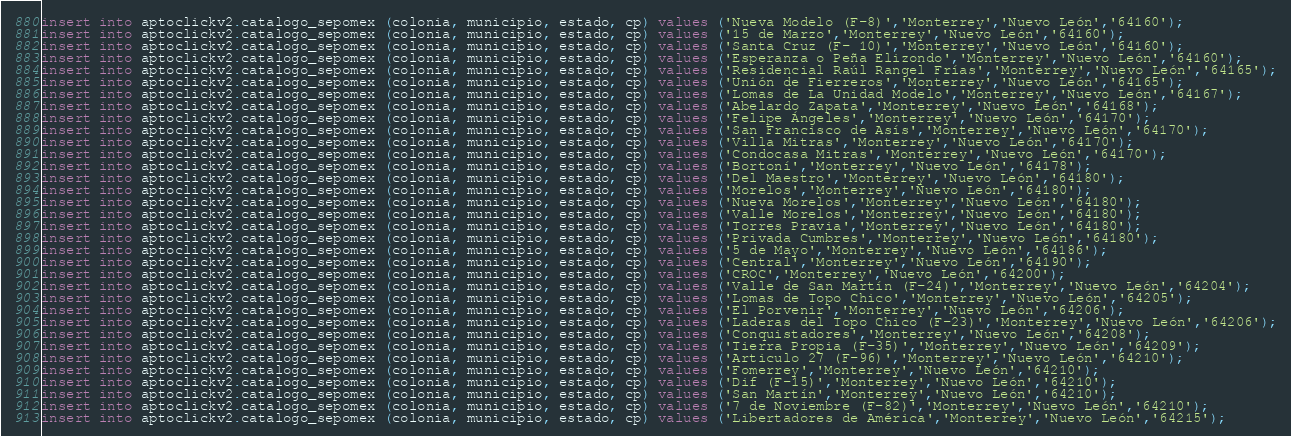Convert code to text. <code><loc_0><loc_0><loc_500><loc_500><_SQL_>insert into aptoclickv2.catalogo_sepomex (colonia, municipio, estado, cp) values ('Nueva Modelo (F-8)','Monterrey','Nuevo León','64160');
insert into aptoclickv2.catalogo_sepomex (colonia, municipio, estado, cp) values ('15 de Marzo','Monterrey','Nuevo León','64160');
insert into aptoclickv2.catalogo_sepomex (colonia, municipio, estado, cp) values ('Santa Cruz (F- 10)','Monterrey','Nuevo León','64160');
insert into aptoclickv2.catalogo_sepomex (colonia, municipio, estado, cp) values ('Esperanza o Peña Elizondo','Monterrey','Nuevo León','64160');
insert into aptoclickv2.catalogo_sepomex (colonia, municipio, estado, cp) values ('Residencial Raúl Rangel Frías','Monterrey','Nuevo León','64165');
insert into aptoclickv2.catalogo_sepomex (colonia, municipio, estado, cp) values ('Unión de Fierreros','Monterrey','Nuevo León','64165');
insert into aptoclickv2.catalogo_sepomex (colonia, municipio, estado, cp) values ('Lomas de La Unidad Modelo','Monterrey','Nuevo León','64167');
insert into aptoclickv2.catalogo_sepomex (colonia, municipio, estado, cp) values ('Abelardo Zapata','Monterrey','Nuevo León','64168');
insert into aptoclickv2.catalogo_sepomex (colonia, municipio, estado, cp) values ('Felipe Ángeles','Monterrey','Nuevo León','64170');
insert into aptoclickv2.catalogo_sepomex (colonia, municipio, estado, cp) values ('San Francisco de Asís','Monterrey','Nuevo León','64170');
insert into aptoclickv2.catalogo_sepomex (colonia, municipio, estado, cp) values ('Villa Mitras','Monterrey','Nuevo León','64170');
insert into aptoclickv2.catalogo_sepomex (colonia, municipio, estado, cp) values ('Condocasa Mitras','Monterrey','Nuevo León','64170');
insert into aptoclickv2.catalogo_sepomex (colonia, municipio, estado, cp) values ('Bortoní','Monterrey','Nuevo León','64178');
insert into aptoclickv2.catalogo_sepomex (colonia, municipio, estado, cp) values ('Del Maestro','Monterrey','Nuevo León','64180');
insert into aptoclickv2.catalogo_sepomex (colonia, municipio, estado, cp) values ('Morelos','Monterrey','Nuevo León','64180');
insert into aptoclickv2.catalogo_sepomex (colonia, municipio, estado, cp) values ('Nueva Morelos','Monterrey','Nuevo León','64180');
insert into aptoclickv2.catalogo_sepomex (colonia, municipio, estado, cp) values ('Valle Morelos','Monterrey','Nuevo León','64180');
insert into aptoclickv2.catalogo_sepomex (colonia, municipio, estado, cp) values ('Torres Pravia','Monterrey','Nuevo León','64180');
insert into aptoclickv2.catalogo_sepomex (colonia, municipio, estado, cp) values ('Privada Cumbres','Monterrey','Nuevo León','64180');
insert into aptoclickv2.catalogo_sepomex (colonia, municipio, estado, cp) values ('5 de Mayo','Monterrey','Nuevo León','64186');
insert into aptoclickv2.catalogo_sepomex (colonia, municipio, estado, cp) values ('Central','Monterrey','Nuevo León','64190');
insert into aptoclickv2.catalogo_sepomex (colonia, municipio, estado, cp) values ('CROC','Monterrey','Nuevo León','64200');
insert into aptoclickv2.catalogo_sepomex (colonia, municipio, estado, cp) values ('Valle de San Martín (F-24)','Monterrey','Nuevo León','64204');
insert into aptoclickv2.catalogo_sepomex (colonia, municipio, estado, cp) values ('Lomas de Topo Chico','Monterrey','Nuevo León','64205');
insert into aptoclickv2.catalogo_sepomex (colonia, municipio, estado, cp) values ('El Porvenir','Monterrey','Nuevo León','64206');
insert into aptoclickv2.catalogo_sepomex (colonia, municipio, estado, cp) values ('Laderas del Topo Chico (F-23)','Monterrey','Nuevo León','64206');
insert into aptoclickv2.catalogo_sepomex (colonia, municipio, estado, cp) values ('Conquistadores','Monterrey','Nuevo León','64208');
insert into aptoclickv2.catalogo_sepomex (colonia, municipio, estado, cp) values ('Tierra Propia (F-35)','Monterrey','Nuevo León','64209');
insert into aptoclickv2.catalogo_sepomex (colonia, municipio, estado, cp) values ('Articulo 27 (F-96)','Monterrey','Nuevo León','64210');
insert into aptoclickv2.catalogo_sepomex (colonia, municipio, estado, cp) values ('Fomerrey','Monterrey','Nuevo León','64210');
insert into aptoclickv2.catalogo_sepomex (colonia, municipio, estado, cp) values ('Dif (F-15)','Monterrey','Nuevo León','64210');
insert into aptoclickv2.catalogo_sepomex (colonia, municipio, estado, cp) values ('San Martín','Monterrey','Nuevo León','64210');
insert into aptoclickv2.catalogo_sepomex (colonia, municipio, estado, cp) values ('7 de Noviembre (F-82)','Monterrey','Nuevo León','64210');
insert into aptoclickv2.catalogo_sepomex (colonia, municipio, estado, cp) values ('Libertadores de América','Monterrey','Nuevo León','64215');</code> 